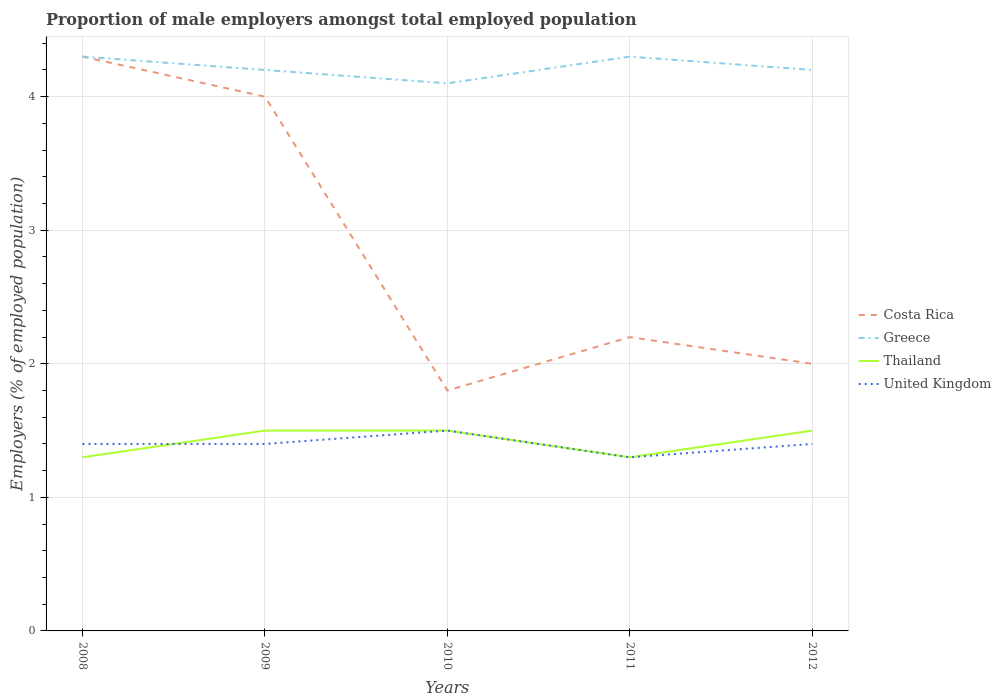How many different coloured lines are there?
Give a very brief answer. 4. Across all years, what is the maximum proportion of male employers in Greece?
Give a very brief answer. 4.1. What is the total proportion of male employers in United Kingdom in the graph?
Provide a short and direct response. -0.1. What is the difference between the highest and the second highest proportion of male employers in United Kingdom?
Offer a terse response. 0.2. What is the difference between the highest and the lowest proportion of male employers in Costa Rica?
Make the answer very short. 2. How many lines are there?
Give a very brief answer. 4. How many years are there in the graph?
Offer a very short reply. 5. Are the values on the major ticks of Y-axis written in scientific E-notation?
Your answer should be compact. No. Does the graph contain any zero values?
Your answer should be very brief. No. Where does the legend appear in the graph?
Provide a succinct answer. Center right. What is the title of the graph?
Your answer should be compact. Proportion of male employers amongst total employed population. Does "Cote d'Ivoire" appear as one of the legend labels in the graph?
Give a very brief answer. No. What is the label or title of the X-axis?
Offer a terse response. Years. What is the label or title of the Y-axis?
Give a very brief answer. Employers (% of employed population). What is the Employers (% of employed population) of Costa Rica in 2008?
Your answer should be compact. 4.3. What is the Employers (% of employed population) in Greece in 2008?
Make the answer very short. 4.3. What is the Employers (% of employed population) of Thailand in 2008?
Keep it short and to the point. 1.3. What is the Employers (% of employed population) of United Kingdom in 2008?
Make the answer very short. 1.4. What is the Employers (% of employed population) in Costa Rica in 2009?
Your answer should be very brief. 4. What is the Employers (% of employed population) in Greece in 2009?
Provide a succinct answer. 4.2. What is the Employers (% of employed population) of United Kingdom in 2009?
Your response must be concise. 1.4. What is the Employers (% of employed population) of Costa Rica in 2010?
Keep it short and to the point. 1.8. What is the Employers (% of employed population) in Greece in 2010?
Ensure brevity in your answer.  4.1. What is the Employers (% of employed population) of Costa Rica in 2011?
Ensure brevity in your answer.  2.2. What is the Employers (% of employed population) in Greece in 2011?
Your answer should be very brief. 4.3. What is the Employers (% of employed population) in Thailand in 2011?
Offer a terse response. 1.3. What is the Employers (% of employed population) of United Kingdom in 2011?
Offer a very short reply. 1.3. What is the Employers (% of employed population) of Greece in 2012?
Your response must be concise. 4.2. What is the Employers (% of employed population) in United Kingdom in 2012?
Offer a very short reply. 1.4. Across all years, what is the maximum Employers (% of employed population) in Costa Rica?
Your response must be concise. 4.3. Across all years, what is the maximum Employers (% of employed population) in Greece?
Keep it short and to the point. 4.3. Across all years, what is the maximum Employers (% of employed population) in United Kingdom?
Keep it short and to the point. 1.5. Across all years, what is the minimum Employers (% of employed population) in Costa Rica?
Provide a short and direct response. 1.8. Across all years, what is the minimum Employers (% of employed population) in Greece?
Your answer should be compact. 4.1. Across all years, what is the minimum Employers (% of employed population) of Thailand?
Your response must be concise. 1.3. Across all years, what is the minimum Employers (% of employed population) of United Kingdom?
Ensure brevity in your answer.  1.3. What is the total Employers (% of employed population) of Greece in the graph?
Your response must be concise. 21.1. What is the total Employers (% of employed population) in Thailand in the graph?
Provide a succinct answer. 7.1. What is the total Employers (% of employed population) in United Kingdom in the graph?
Give a very brief answer. 7. What is the difference between the Employers (% of employed population) in Greece in 2008 and that in 2009?
Your response must be concise. 0.1. What is the difference between the Employers (% of employed population) in United Kingdom in 2008 and that in 2009?
Your answer should be compact. 0. What is the difference between the Employers (% of employed population) in Greece in 2008 and that in 2010?
Keep it short and to the point. 0.2. What is the difference between the Employers (% of employed population) of Thailand in 2008 and that in 2010?
Ensure brevity in your answer.  -0.2. What is the difference between the Employers (% of employed population) in Costa Rica in 2008 and that in 2011?
Provide a succinct answer. 2.1. What is the difference between the Employers (% of employed population) of Thailand in 2009 and that in 2010?
Offer a terse response. 0. What is the difference between the Employers (% of employed population) of Costa Rica in 2009 and that in 2011?
Provide a succinct answer. 1.8. What is the difference between the Employers (% of employed population) in Greece in 2009 and that in 2011?
Give a very brief answer. -0.1. What is the difference between the Employers (% of employed population) in Thailand in 2009 and that in 2011?
Keep it short and to the point. 0.2. What is the difference between the Employers (% of employed population) of Costa Rica in 2009 and that in 2012?
Give a very brief answer. 2. What is the difference between the Employers (% of employed population) of Greece in 2009 and that in 2012?
Provide a succinct answer. 0. What is the difference between the Employers (% of employed population) in Thailand in 2009 and that in 2012?
Your answer should be compact. 0. What is the difference between the Employers (% of employed population) in United Kingdom in 2009 and that in 2012?
Ensure brevity in your answer.  0. What is the difference between the Employers (% of employed population) of Costa Rica in 2010 and that in 2011?
Provide a short and direct response. -0.4. What is the difference between the Employers (% of employed population) in Thailand in 2010 and that in 2011?
Provide a succinct answer. 0.2. What is the difference between the Employers (% of employed population) of Costa Rica in 2010 and that in 2012?
Ensure brevity in your answer.  -0.2. What is the difference between the Employers (% of employed population) of United Kingdom in 2010 and that in 2012?
Provide a short and direct response. 0.1. What is the difference between the Employers (% of employed population) of Costa Rica in 2011 and that in 2012?
Your response must be concise. 0.2. What is the difference between the Employers (% of employed population) in Costa Rica in 2008 and the Employers (% of employed population) in Greece in 2009?
Your answer should be very brief. 0.1. What is the difference between the Employers (% of employed population) in Costa Rica in 2008 and the Employers (% of employed population) in Thailand in 2009?
Provide a short and direct response. 2.8. What is the difference between the Employers (% of employed population) of Thailand in 2008 and the Employers (% of employed population) of United Kingdom in 2009?
Give a very brief answer. -0.1. What is the difference between the Employers (% of employed population) in Costa Rica in 2008 and the Employers (% of employed population) in Greece in 2010?
Offer a very short reply. 0.2. What is the difference between the Employers (% of employed population) in Costa Rica in 2008 and the Employers (% of employed population) in United Kingdom in 2010?
Your response must be concise. 2.8. What is the difference between the Employers (% of employed population) in Greece in 2008 and the Employers (% of employed population) in United Kingdom in 2010?
Your response must be concise. 2.8. What is the difference between the Employers (% of employed population) in Costa Rica in 2008 and the Employers (% of employed population) in Thailand in 2011?
Make the answer very short. 3. What is the difference between the Employers (% of employed population) of Greece in 2008 and the Employers (% of employed population) of Thailand in 2011?
Your answer should be compact. 3. What is the difference between the Employers (% of employed population) in Greece in 2008 and the Employers (% of employed population) in United Kingdom in 2011?
Provide a short and direct response. 3. What is the difference between the Employers (% of employed population) in Costa Rica in 2008 and the Employers (% of employed population) in United Kingdom in 2012?
Ensure brevity in your answer.  2.9. What is the difference between the Employers (% of employed population) of Greece in 2008 and the Employers (% of employed population) of United Kingdom in 2012?
Give a very brief answer. 2.9. What is the difference between the Employers (% of employed population) in Thailand in 2008 and the Employers (% of employed population) in United Kingdom in 2012?
Provide a short and direct response. -0.1. What is the difference between the Employers (% of employed population) in Costa Rica in 2009 and the Employers (% of employed population) in Thailand in 2010?
Ensure brevity in your answer.  2.5. What is the difference between the Employers (% of employed population) of Greece in 2009 and the Employers (% of employed population) of Thailand in 2010?
Your answer should be very brief. 2.7. What is the difference between the Employers (% of employed population) in Greece in 2009 and the Employers (% of employed population) in United Kingdom in 2010?
Ensure brevity in your answer.  2.7. What is the difference between the Employers (% of employed population) of Costa Rica in 2009 and the Employers (% of employed population) of United Kingdom in 2011?
Ensure brevity in your answer.  2.7. What is the difference between the Employers (% of employed population) in Greece in 2009 and the Employers (% of employed population) in Thailand in 2011?
Offer a terse response. 2.9. What is the difference between the Employers (% of employed population) in Greece in 2009 and the Employers (% of employed population) in United Kingdom in 2011?
Your answer should be very brief. 2.9. What is the difference between the Employers (% of employed population) of Thailand in 2009 and the Employers (% of employed population) of United Kingdom in 2011?
Your answer should be compact. 0.2. What is the difference between the Employers (% of employed population) in Greece in 2009 and the Employers (% of employed population) in Thailand in 2012?
Offer a very short reply. 2.7. What is the difference between the Employers (% of employed population) of Greece in 2009 and the Employers (% of employed population) of United Kingdom in 2012?
Provide a short and direct response. 2.8. What is the difference between the Employers (% of employed population) of Thailand in 2009 and the Employers (% of employed population) of United Kingdom in 2012?
Give a very brief answer. 0.1. What is the difference between the Employers (% of employed population) of Costa Rica in 2010 and the Employers (% of employed population) of Greece in 2011?
Give a very brief answer. -2.5. What is the difference between the Employers (% of employed population) in Costa Rica in 2010 and the Employers (% of employed population) in United Kingdom in 2011?
Your answer should be very brief. 0.5. What is the difference between the Employers (% of employed population) of Greece in 2010 and the Employers (% of employed population) of Thailand in 2011?
Keep it short and to the point. 2.8. What is the difference between the Employers (% of employed population) of Thailand in 2010 and the Employers (% of employed population) of United Kingdom in 2011?
Make the answer very short. 0.2. What is the difference between the Employers (% of employed population) in Costa Rica in 2010 and the Employers (% of employed population) in Thailand in 2012?
Your response must be concise. 0.3. What is the difference between the Employers (% of employed population) in Greece in 2010 and the Employers (% of employed population) in Thailand in 2012?
Offer a terse response. 2.6. What is the difference between the Employers (% of employed population) of Costa Rica in 2011 and the Employers (% of employed population) of Thailand in 2012?
Give a very brief answer. 0.7. What is the difference between the Employers (% of employed population) of Costa Rica in 2011 and the Employers (% of employed population) of United Kingdom in 2012?
Offer a terse response. 0.8. What is the difference between the Employers (% of employed population) in Thailand in 2011 and the Employers (% of employed population) in United Kingdom in 2012?
Offer a very short reply. -0.1. What is the average Employers (% of employed population) in Costa Rica per year?
Make the answer very short. 2.86. What is the average Employers (% of employed population) of Greece per year?
Provide a succinct answer. 4.22. What is the average Employers (% of employed population) in Thailand per year?
Your response must be concise. 1.42. In the year 2008, what is the difference between the Employers (% of employed population) of Costa Rica and Employers (% of employed population) of Greece?
Ensure brevity in your answer.  0. In the year 2008, what is the difference between the Employers (% of employed population) of Costa Rica and Employers (% of employed population) of Thailand?
Ensure brevity in your answer.  3. In the year 2008, what is the difference between the Employers (% of employed population) in Costa Rica and Employers (% of employed population) in United Kingdom?
Make the answer very short. 2.9. In the year 2008, what is the difference between the Employers (% of employed population) of Greece and Employers (% of employed population) of Thailand?
Provide a succinct answer. 3. In the year 2008, what is the difference between the Employers (% of employed population) of Greece and Employers (% of employed population) of United Kingdom?
Make the answer very short. 2.9. In the year 2009, what is the difference between the Employers (% of employed population) in Costa Rica and Employers (% of employed population) in Greece?
Ensure brevity in your answer.  -0.2. In the year 2009, what is the difference between the Employers (% of employed population) in Costa Rica and Employers (% of employed population) in United Kingdom?
Make the answer very short. 2.6. In the year 2009, what is the difference between the Employers (% of employed population) of Greece and Employers (% of employed population) of Thailand?
Your answer should be compact. 2.7. In the year 2009, what is the difference between the Employers (% of employed population) of Greece and Employers (% of employed population) of United Kingdom?
Your response must be concise. 2.8. In the year 2010, what is the difference between the Employers (% of employed population) in Costa Rica and Employers (% of employed population) in Greece?
Provide a short and direct response. -2.3. In the year 2010, what is the difference between the Employers (% of employed population) of Costa Rica and Employers (% of employed population) of Thailand?
Your answer should be very brief. 0.3. In the year 2010, what is the difference between the Employers (% of employed population) in Costa Rica and Employers (% of employed population) in United Kingdom?
Your answer should be compact. 0.3. In the year 2010, what is the difference between the Employers (% of employed population) of Greece and Employers (% of employed population) of United Kingdom?
Your answer should be very brief. 2.6. In the year 2011, what is the difference between the Employers (% of employed population) in Costa Rica and Employers (% of employed population) in Thailand?
Provide a succinct answer. 0.9. In the year 2011, what is the difference between the Employers (% of employed population) in Greece and Employers (% of employed population) in Thailand?
Provide a succinct answer. 3. In the year 2011, what is the difference between the Employers (% of employed population) in Greece and Employers (% of employed population) in United Kingdom?
Provide a short and direct response. 3. In the year 2012, what is the difference between the Employers (% of employed population) of Costa Rica and Employers (% of employed population) of United Kingdom?
Offer a terse response. 0.6. In the year 2012, what is the difference between the Employers (% of employed population) in Greece and Employers (% of employed population) in Thailand?
Give a very brief answer. 2.7. In the year 2012, what is the difference between the Employers (% of employed population) of Greece and Employers (% of employed population) of United Kingdom?
Make the answer very short. 2.8. What is the ratio of the Employers (% of employed population) of Costa Rica in 2008 to that in 2009?
Provide a succinct answer. 1.07. What is the ratio of the Employers (% of employed population) in Greece in 2008 to that in 2009?
Provide a short and direct response. 1.02. What is the ratio of the Employers (% of employed population) in Thailand in 2008 to that in 2009?
Give a very brief answer. 0.87. What is the ratio of the Employers (% of employed population) in Costa Rica in 2008 to that in 2010?
Your answer should be compact. 2.39. What is the ratio of the Employers (% of employed population) in Greece in 2008 to that in 2010?
Give a very brief answer. 1.05. What is the ratio of the Employers (% of employed population) in Thailand in 2008 to that in 2010?
Ensure brevity in your answer.  0.87. What is the ratio of the Employers (% of employed population) in Costa Rica in 2008 to that in 2011?
Your answer should be very brief. 1.95. What is the ratio of the Employers (% of employed population) in Thailand in 2008 to that in 2011?
Keep it short and to the point. 1. What is the ratio of the Employers (% of employed population) of United Kingdom in 2008 to that in 2011?
Give a very brief answer. 1.08. What is the ratio of the Employers (% of employed population) of Costa Rica in 2008 to that in 2012?
Make the answer very short. 2.15. What is the ratio of the Employers (% of employed population) of Greece in 2008 to that in 2012?
Offer a terse response. 1.02. What is the ratio of the Employers (% of employed population) in Thailand in 2008 to that in 2012?
Your response must be concise. 0.87. What is the ratio of the Employers (% of employed population) in Costa Rica in 2009 to that in 2010?
Your response must be concise. 2.22. What is the ratio of the Employers (% of employed population) in Greece in 2009 to that in 2010?
Keep it short and to the point. 1.02. What is the ratio of the Employers (% of employed population) in Thailand in 2009 to that in 2010?
Your answer should be compact. 1. What is the ratio of the Employers (% of employed population) of United Kingdom in 2009 to that in 2010?
Offer a very short reply. 0.93. What is the ratio of the Employers (% of employed population) in Costa Rica in 2009 to that in 2011?
Offer a terse response. 1.82. What is the ratio of the Employers (% of employed population) in Greece in 2009 to that in 2011?
Provide a succinct answer. 0.98. What is the ratio of the Employers (% of employed population) in Thailand in 2009 to that in 2011?
Keep it short and to the point. 1.15. What is the ratio of the Employers (% of employed population) of Costa Rica in 2010 to that in 2011?
Give a very brief answer. 0.82. What is the ratio of the Employers (% of employed population) in Greece in 2010 to that in 2011?
Offer a very short reply. 0.95. What is the ratio of the Employers (% of employed population) in Thailand in 2010 to that in 2011?
Provide a short and direct response. 1.15. What is the ratio of the Employers (% of employed population) in United Kingdom in 2010 to that in 2011?
Your answer should be compact. 1.15. What is the ratio of the Employers (% of employed population) in Costa Rica in 2010 to that in 2012?
Keep it short and to the point. 0.9. What is the ratio of the Employers (% of employed population) of Greece in 2010 to that in 2012?
Ensure brevity in your answer.  0.98. What is the ratio of the Employers (% of employed population) of Thailand in 2010 to that in 2012?
Make the answer very short. 1. What is the ratio of the Employers (% of employed population) of United Kingdom in 2010 to that in 2012?
Your answer should be compact. 1.07. What is the ratio of the Employers (% of employed population) of Costa Rica in 2011 to that in 2012?
Make the answer very short. 1.1. What is the ratio of the Employers (% of employed population) of Greece in 2011 to that in 2012?
Give a very brief answer. 1.02. What is the ratio of the Employers (% of employed population) of Thailand in 2011 to that in 2012?
Provide a short and direct response. 0.87. What is the difference between the highest and the second highest Employers (% of employed population) in Costa Rica?
Keep it short and to the point. 0.3. What is the difference between the highest and the second highest Employers (% of employed population) of Thailand?
Your answer should be compact. 0. What is the difference between the highest and the lowest Employers (% of employed population) of Costa Rica?
Keep it short and to the point. 2.5. 